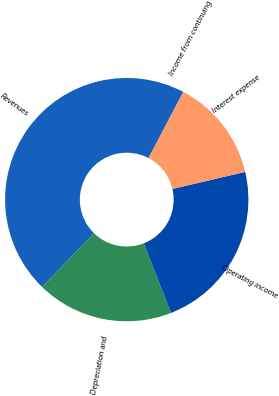Convert chart to OTSL. <chart><loc_0><loc_0><loc_500><loc_500><pie_chart><fcel>Revenues<fcel>Depreciation and<fcel>Operating income<fcel>Interest expense<fcel>Income from continuing<nl><fcel>45.45%<fcel>18.18%<fcel>22.73%<fcel>13.64%<fcel>0.01%<nl></chart> 